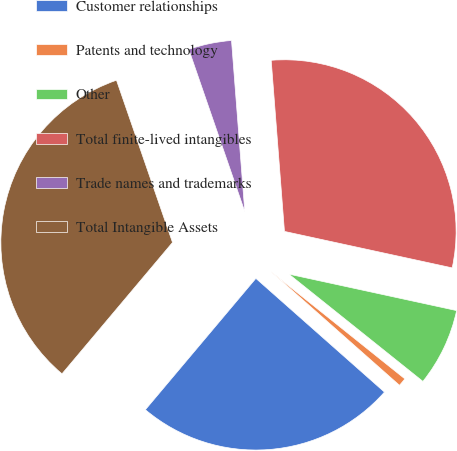Convert chart. <chart><loc_0><loc_0><loc_500><loc_500><pie_chart><fcel>Customer relationships<fcel>Patents and technology<fcel>Other<fcel>Total finite-lived intangibles<fcel>Trade names and trademarks<fcel>Total Intangible Assets<nl><fcel>24.61%<fcel>0.78%<fcel>7.34%<fcel>29.64%<fcel>4.06%<fcel>33.58%<nl></chart> 